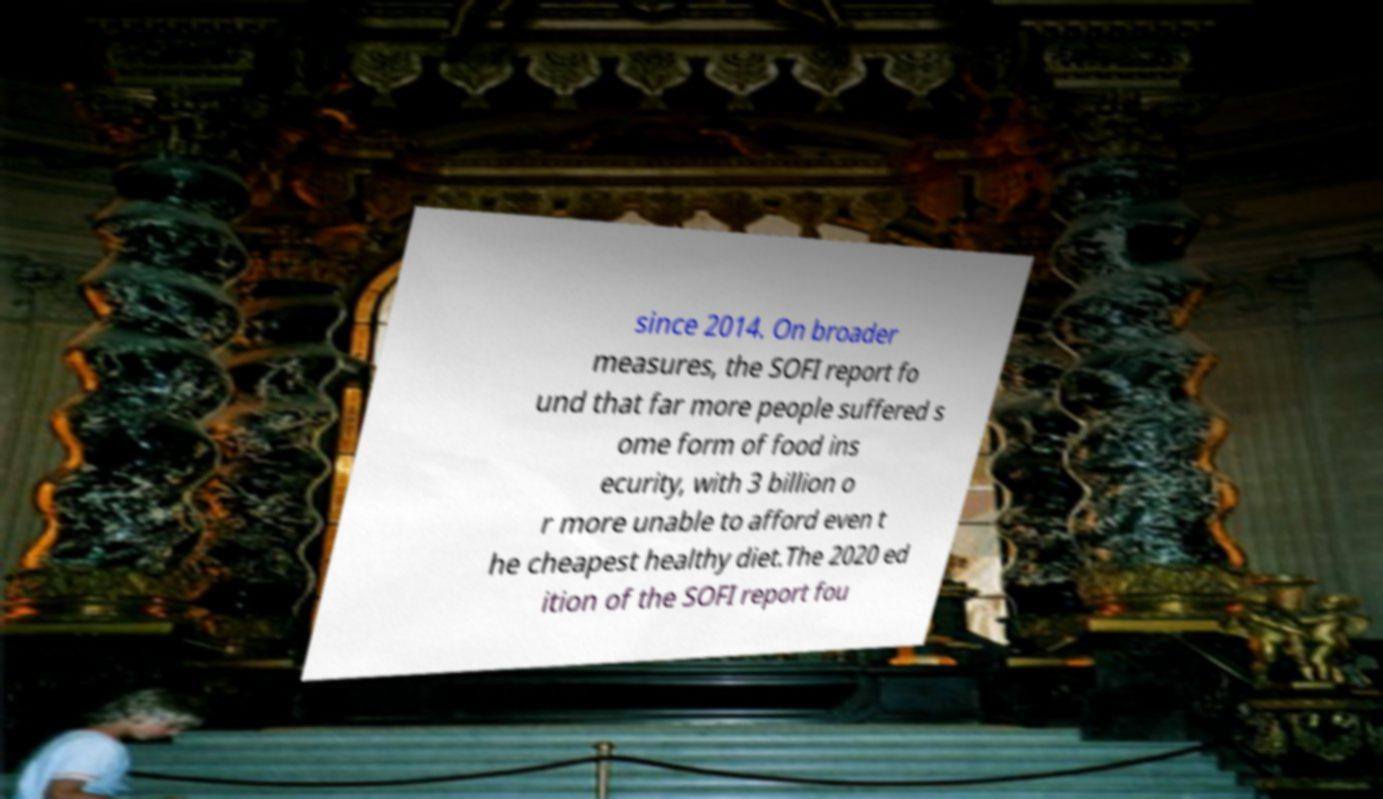Could you extract and type out the text from this image? since 2014. On broader measures, the SOFI report fo und that far more people suffered s ome form of food ins ecurity, with 3 billion o r more unable to afford even t he cheapest healthy diet.The 2020 ed ition of the SOFI report fou 